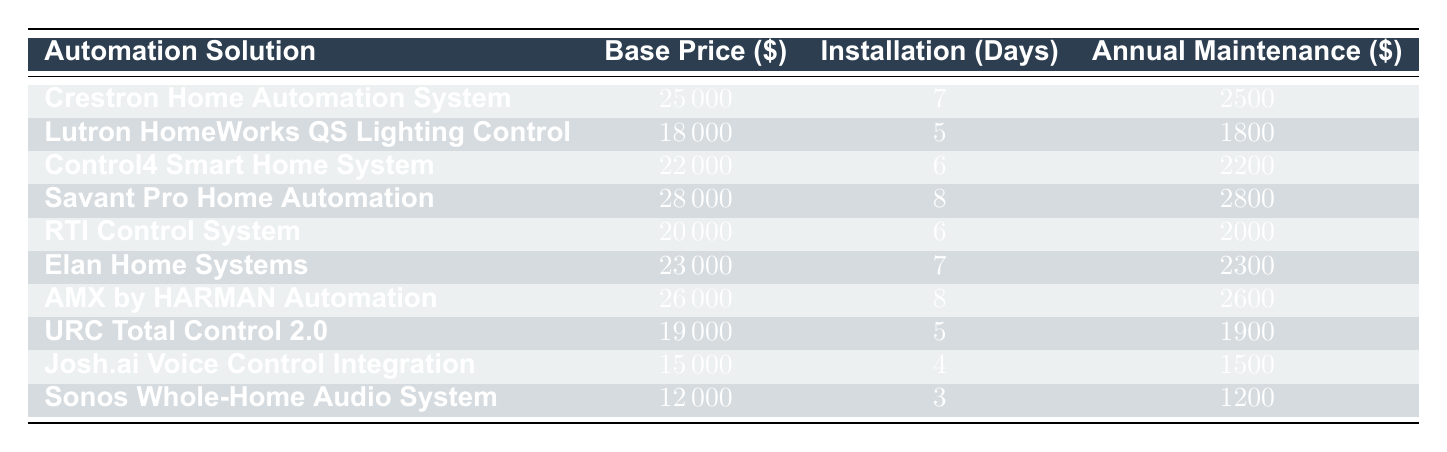What is the base price of the Crestron Home Automation System? The table lists the base price for the Crestron Home Automation System directly under the "Base Price (USD)" column. It is shown as 25000.
Answer: 25000 Which automation solution has the lowest annual maintenance cost? By comparing the "Annual Maintenance Cost (USD)" column, the Sonos Whole-Home Audio System has the lowest maintenance cost of 1200.
Answer: 1200 What is the total base price of the two most expensive automation solutions? The two most expensive solutions are Savant Pro Home Automation (28000) and AMX by HARMAN Automation (26000). Adding these gives us 28000 + 26000 = 54000.
Answer: 54000 Is the installation time for the Lutron HomeWorks QS Lighting Control greater than 5 days? The installation time for Lutron HomeWorks QS Lighting Control is listed as 5 days, which means it is not greater than 5 days. This makes the answer "no."
Answer: No What is the average annual maintenance cost of the listed automation solutions? To find the average, we add up all the annual maintenance costs: 2500 + 1800 + 2200 + 2800 + 2000 + 2300 + 2600 + 1900 + 1500 + 1200 = 22600. There are 10 solutions, so we divide 22600 by 10, resulting in 2260.
Answer: 2260 Which automation solution has the longest installation time? By reviewing the "Installation Time (Days)" column, Savant Pro Home Automation has the longest installation time of 8 days.
Answer: 8 Is the base price of the Josh.ai Voice Control Integration less than 20000? The base price for Josh.ai Voice Control Integration is 15000, which is indeed less than 20000. Therefore, the answer is "yes."
Answer: Yes What is the difference in base price between the most expensive and the least expensive automation solutions? The most expensive solution is Savant Pro Home Automation at 28000, and the least expensive is Sonos Whole-Home Audio System at 12000. The difference is calculated by 28000 - 12000, which equals 16000.
Answer: 16000 